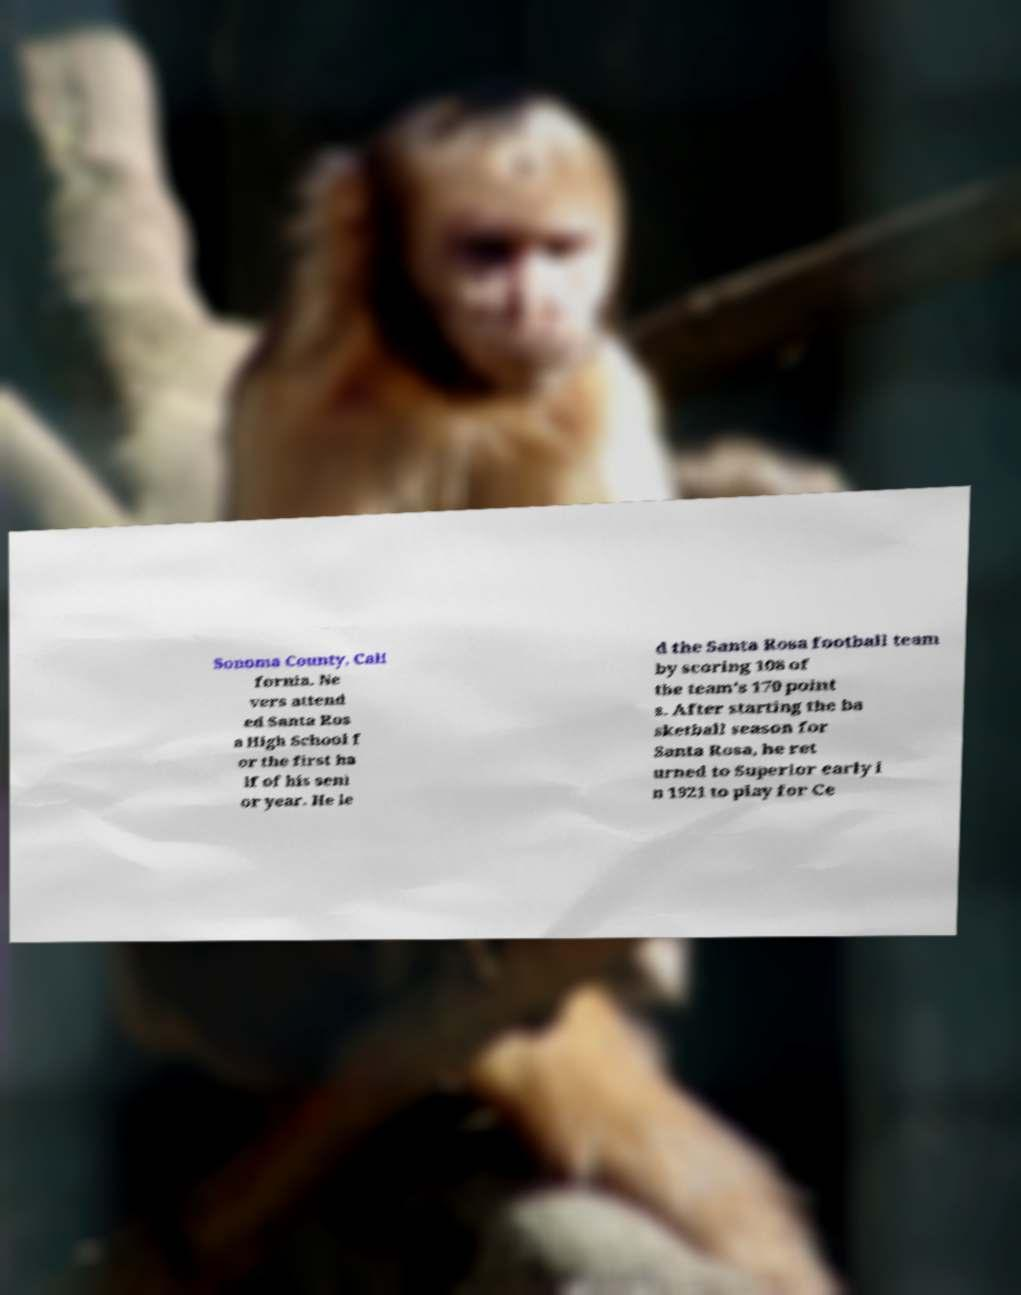Could you extract and type out the text from this image? Sonoma County, Cali fornia. Ne vers attend ed Santa Ros a High School f or the first ha lf of his seni or year. He le d the Santa Rosa football team by scoring 108 of the team's 170 point s. After starting the ba sketball season for Santa Rosa, he ret urned to Superior early i n 1921 to play for Ce 